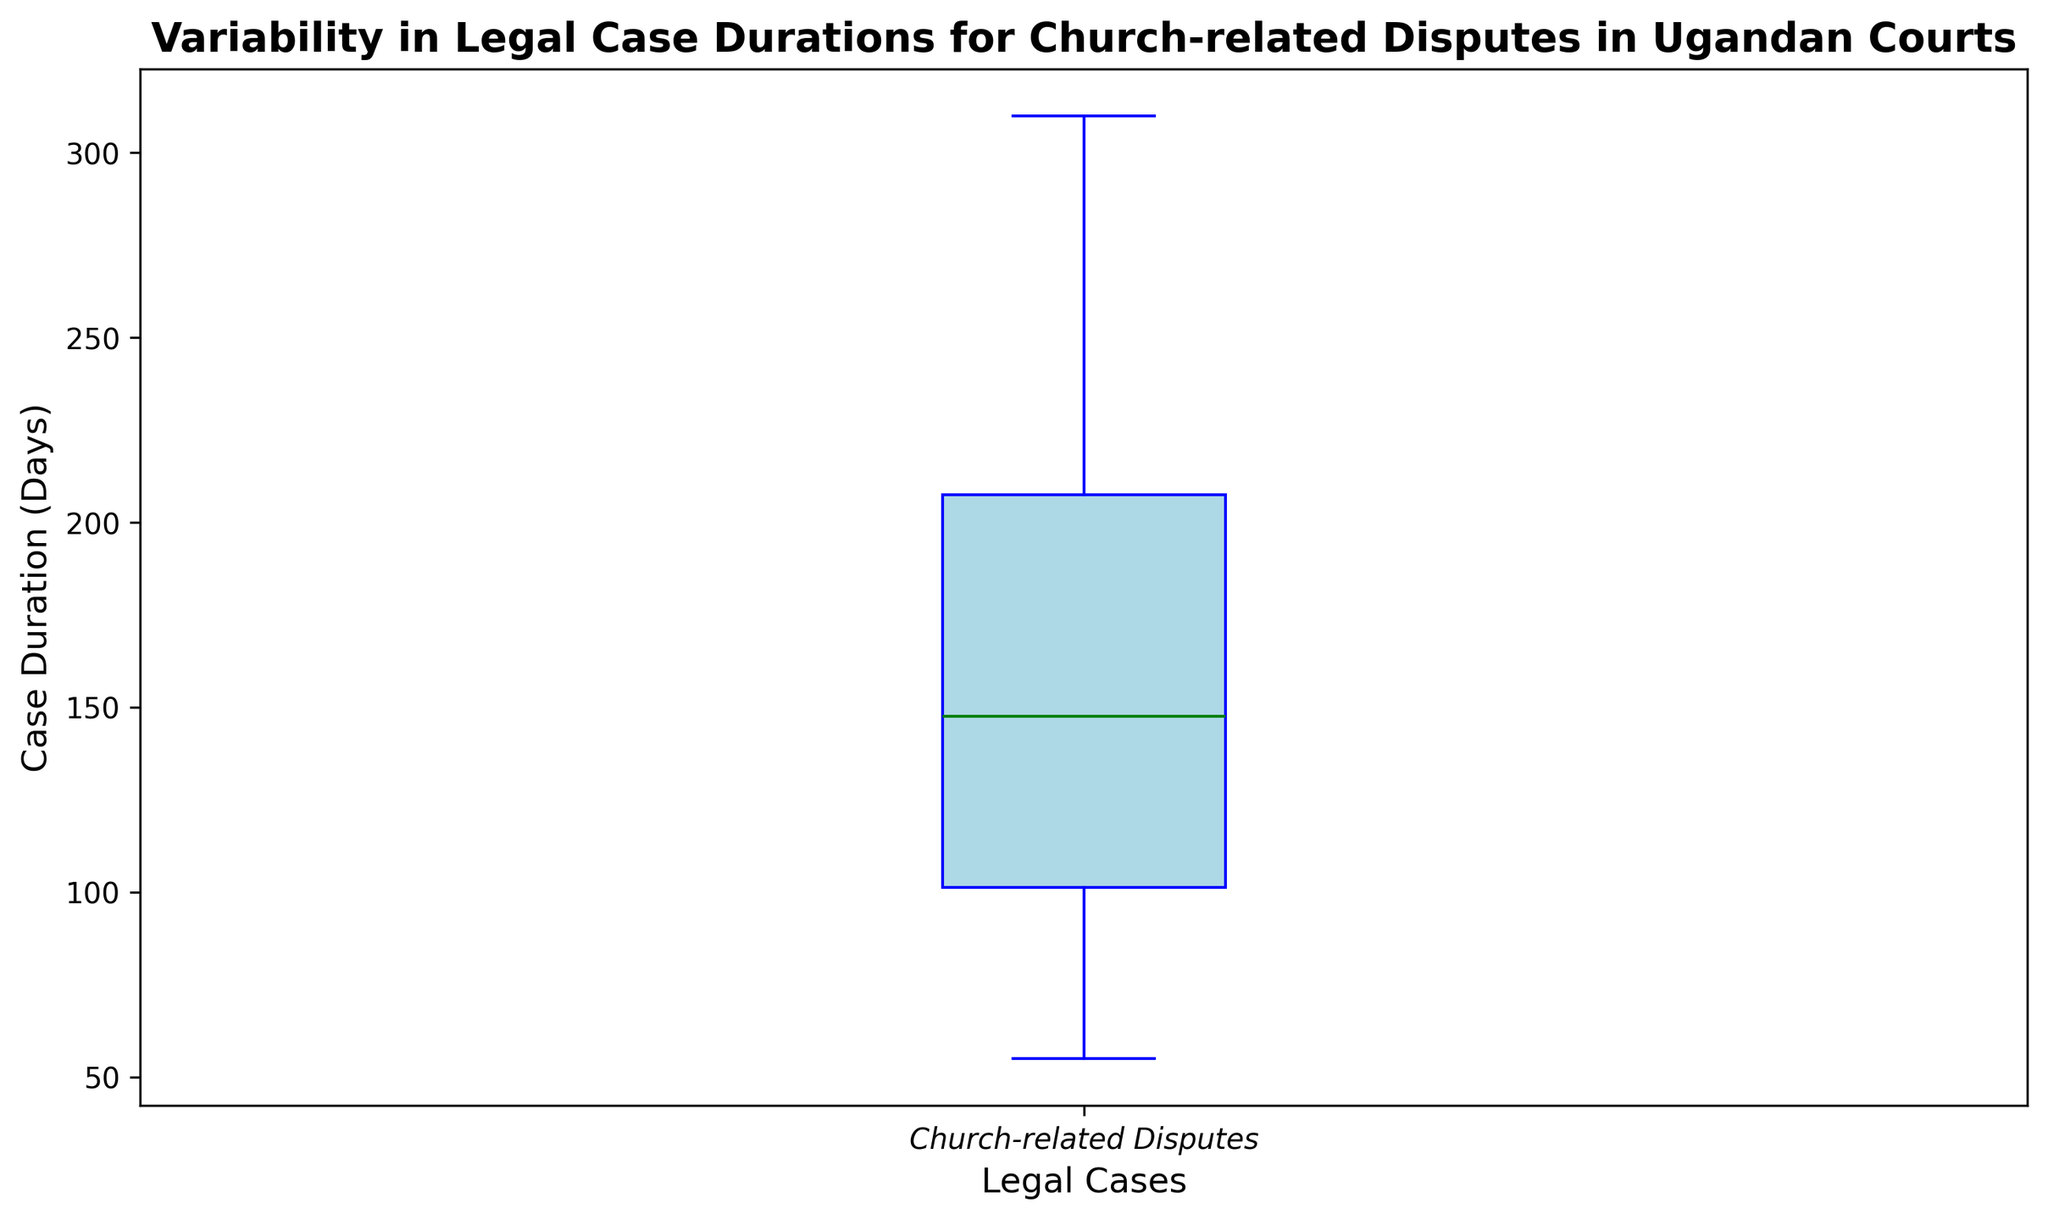What is the median case duration for church-related disputes in Ugandan courts? The median is the middle value of the dataset when ordered from least to greatest. For a box plot, the median is indicated by the line inside the box.
Answer: 150 days Does the box plot show any outliers, and if so, how many? Outliers are displayed in the box plot as individual data points outside the whiskers. In this case, there are several outliers marked by red dots.
Answer: 5 outliers What is the interquartile range (IQR) of the case durations? The IQR is the difference between the third quartile (Q3) and first quartile (Q1). Q3 is the top of the box, and Q1 is the bottom of the box.
Answer: 105 days What is the minimum reported duration for church-related legal cases, excluding outliers? The minimum is marked by the bottom whisker of the box plot. This excludes any outliers.
Answer: 60 days Which duration value(s) represent the outliers? Outliers are represented as red dots outside the whiskers of the box plot. The durations of the outliers can be read directly from these points.
Answer: 310, 300, 280, 265, 260 days How does the median case duration compare to the upper quartile (Q3)? The median is the middle value, and Q3 is the value at the top of the box. By comparing their positions, we can see if the median is less than or greater than Q3.
Answer: less than Q3 What visual feature makes it easy to identify the spread of the main body of case durations? The box plot's interquartile range (IQR) is represented by the height of the main box, which makes it easy to see the spread of the middle 50% of the data.
Answer: Height of the box In terms of variability, what does the box plot say about the case durations? The greater the distance between Q1 and Q3 in the box plot, the more variability there is among the middle 50% of the durations. Also, the length of the whiskers indicates the range of the data, excluding outliers.
Answer: High variability Which visual aspects indicate the skewness of the case duration distribution? The position of the median line within the box and the length of the whiskers can indicate skewness. If the median is closer to Q1 or Q3, and if one whisker is significantly longer, it suggests skewness.
Answer: Median line, whiskers 